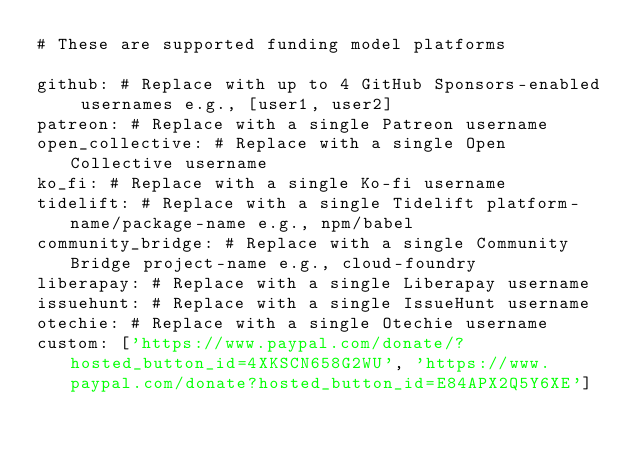<code> <loc_0><loc_0><loc_500><loc_500><_YAML_># These are supported funding model platforms

github: # Replace with up to 4 GitHub Sponsors-enabled usernames e.g., [user1, user2]
patreon: # Replace with a single Patreon username
open_collective: # Replace with a single Open Collective username
ko_fi: # Replace with a single Ko-fi username
tidelift: # Replace with a single Tidelift platform-name/package-name e.g., npm/babel
community_bridge: # Replace with a single Community Bridge project-name e.g., cloud-foundry
liberapay: # Replace with a single Liberapay username
issuehunt: # Replace with a single IssueHunt username
otechie: # Replace with a single Otechie username
custom: ['https://www.paypal.com/donate/?hosted_button_id=4XKSCN658G2WU', 'https://www.paypal.com/donate?hosted_button_id=E84APX2Q5Y6XE']
</code> 